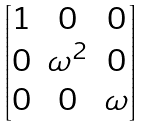Convert formula to latex. <formula><loc_0><loc_0><loc_500><loc_500>\begin{bmatrix} 1 & 0 & 0 \\ 0 & \omega ^ { 2 } & 0 \\ 0 & 0 & \omega \\ \end{bmatrix}</formula> 